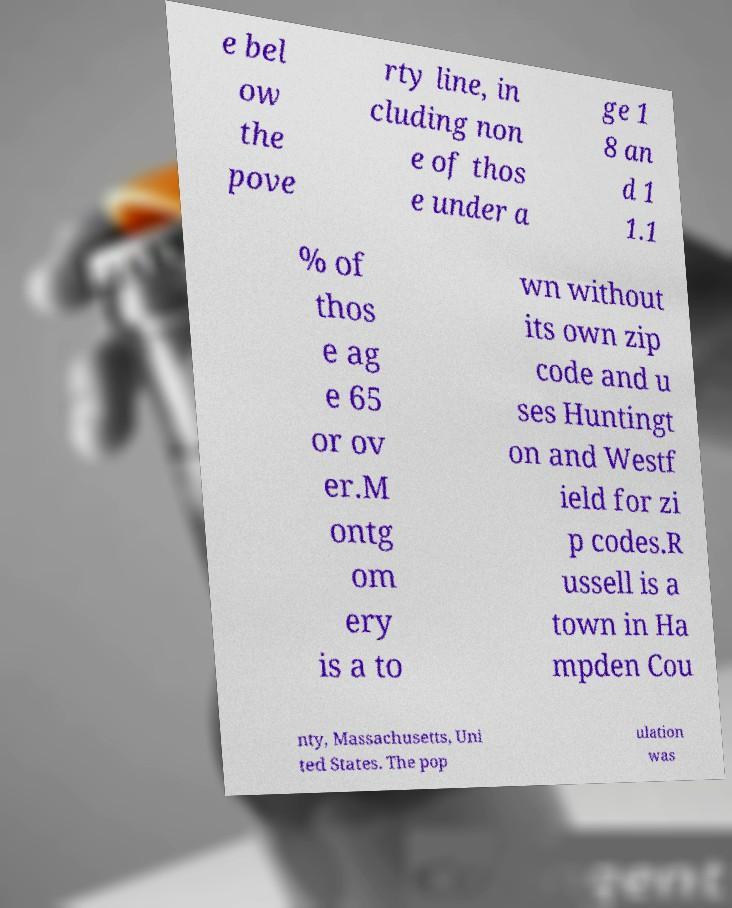Please read and relay the text visible in this image. What does it say? e bel ow the pove rty line, in cluding non e of thos e under a ge 1 8 an d 1 1.1 % of thos e ag e 65 or ov er.M ontg om ery is a to wn without its own zip code and u ses Huntingt on and Westf ield for zi p codes.R ussell is a town in Ha mpden Cou nty, Massachusetts, Uni ted States. The pop ulation was 